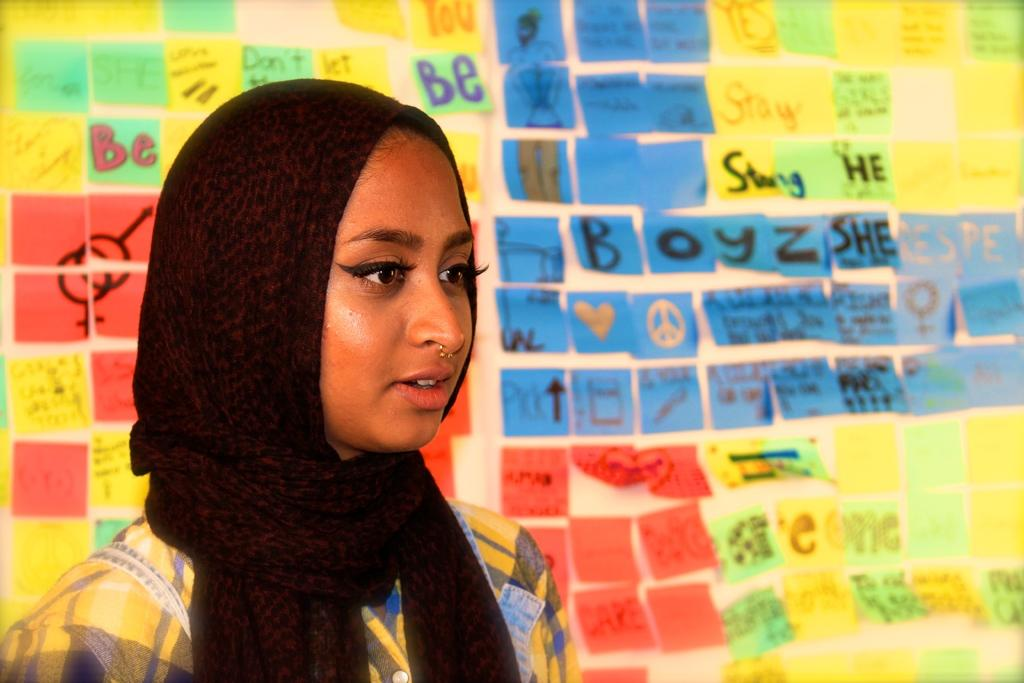Who is the main subject in the image? There is a woman in the image. Where is the woman located in the image? The woman is on the left side of the image. What is the woman wearing on her head? The woman is wearing a scarf on her head. What can be seen in the background of the image? There are colorful papers on the wall in the background of the image. What type of record can be seen on the woman's neck in the image? There is no record present in the image; the woman is wearing a scarf on her head. 